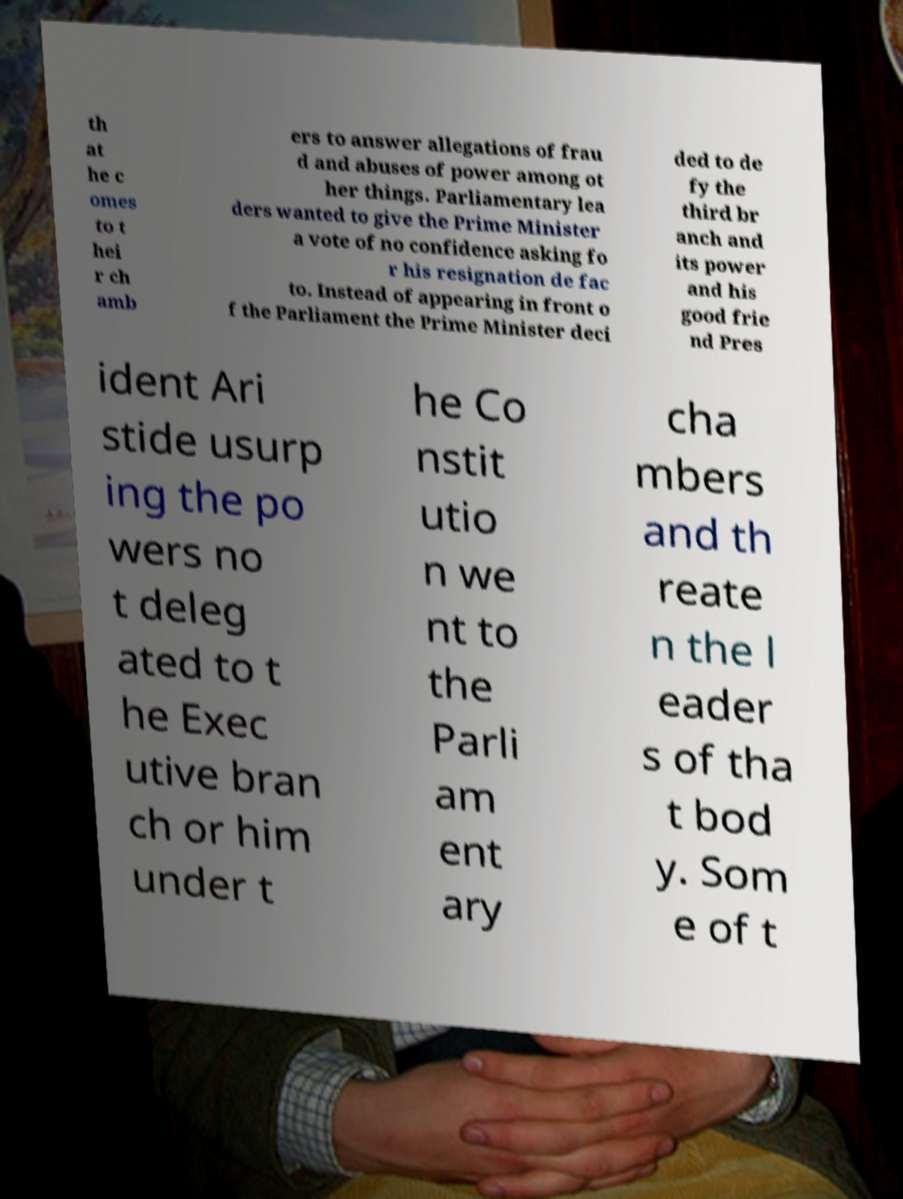Please identify and transcribe the text found in this image. th at he c omes to t hei r ch amb ers to answer allegations of frau d and abuses of power among ot her things. Parliamentary lea ders wanted to give the Prime Minister a vote of no confidence asking fo r his resignation de fac to. Instead of appearing in front o f the Parliament the Prime Minister deci ded to de fy the third br anch and its power and his good frie nd Pres ident Ari stide usurp ing the po wers no t deleg ated to t he Exec utive bran ch or him under t he Co nstit utio n we nt to the Parli am ent ary cha mbers and th reate n the l eader s of tha t bod y. Som e of t 